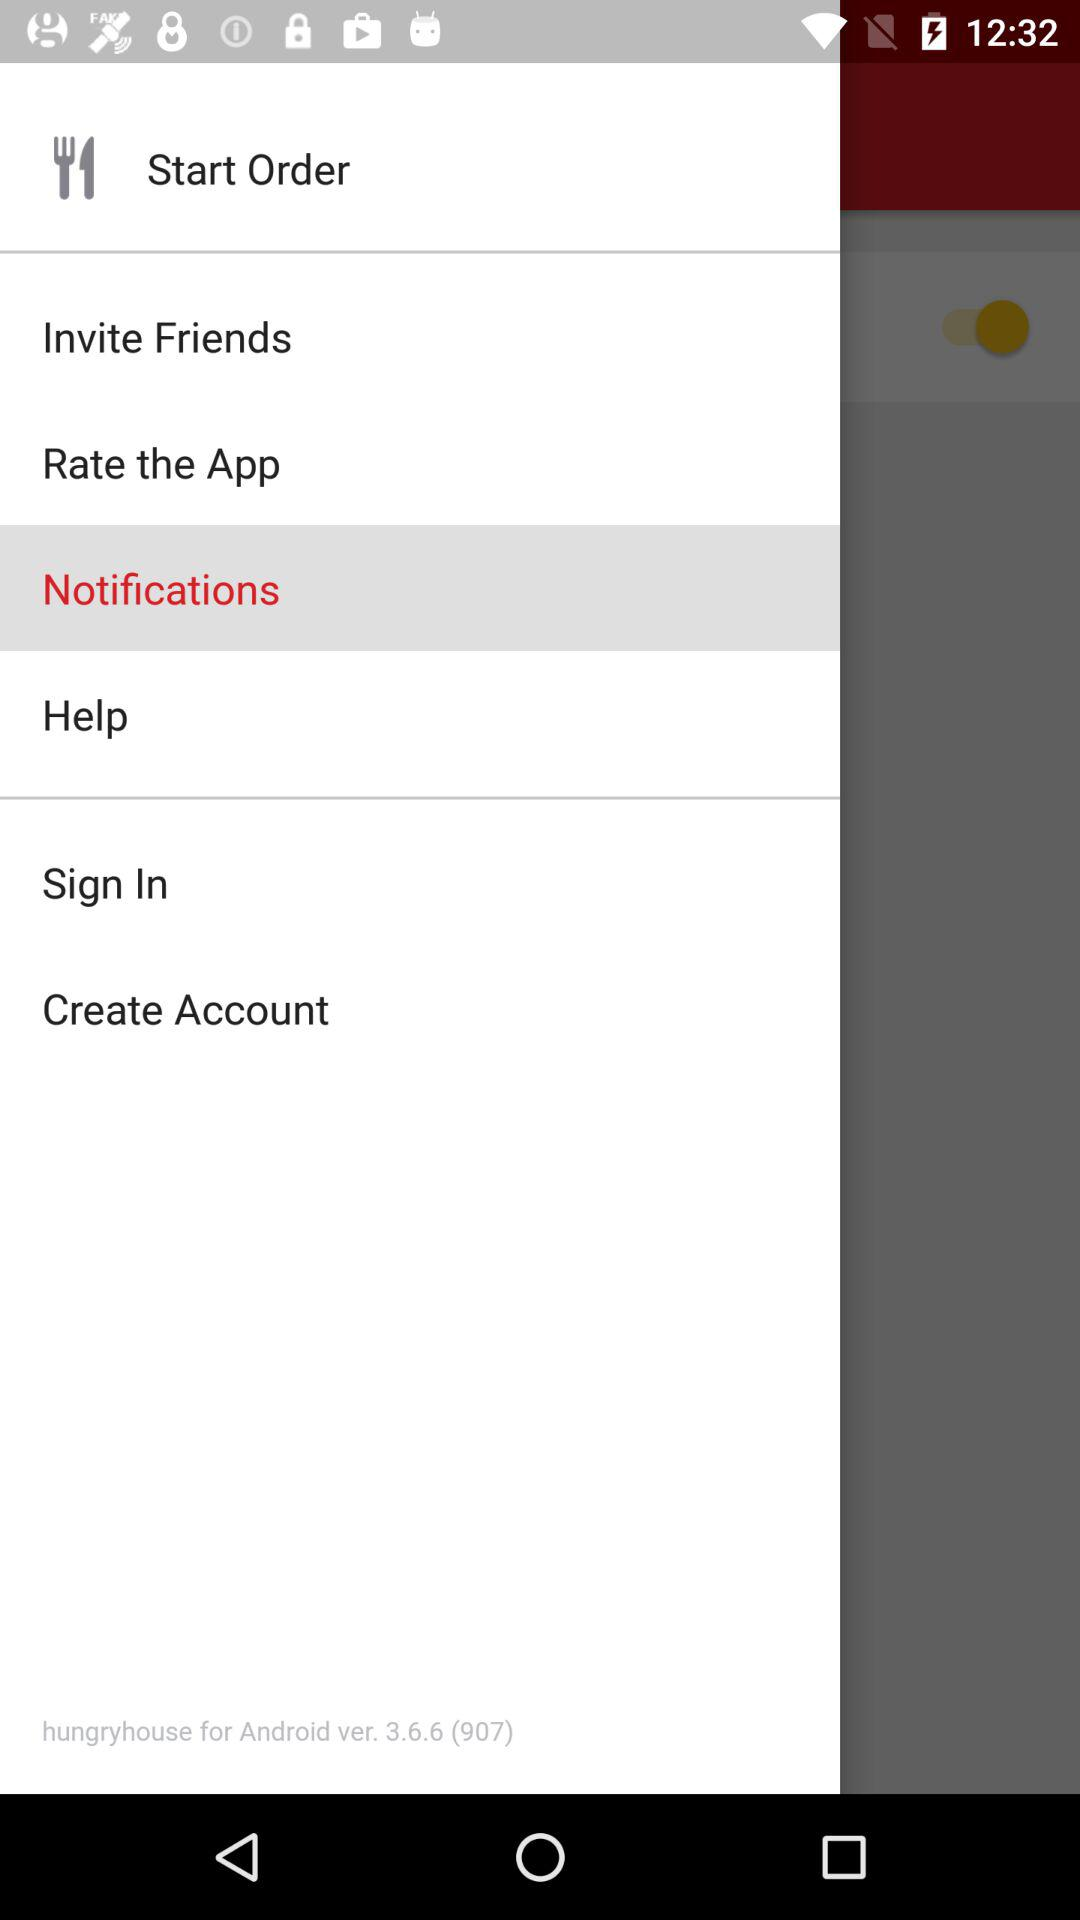Which item is selected in the menu? The selected item is "Notifications". 